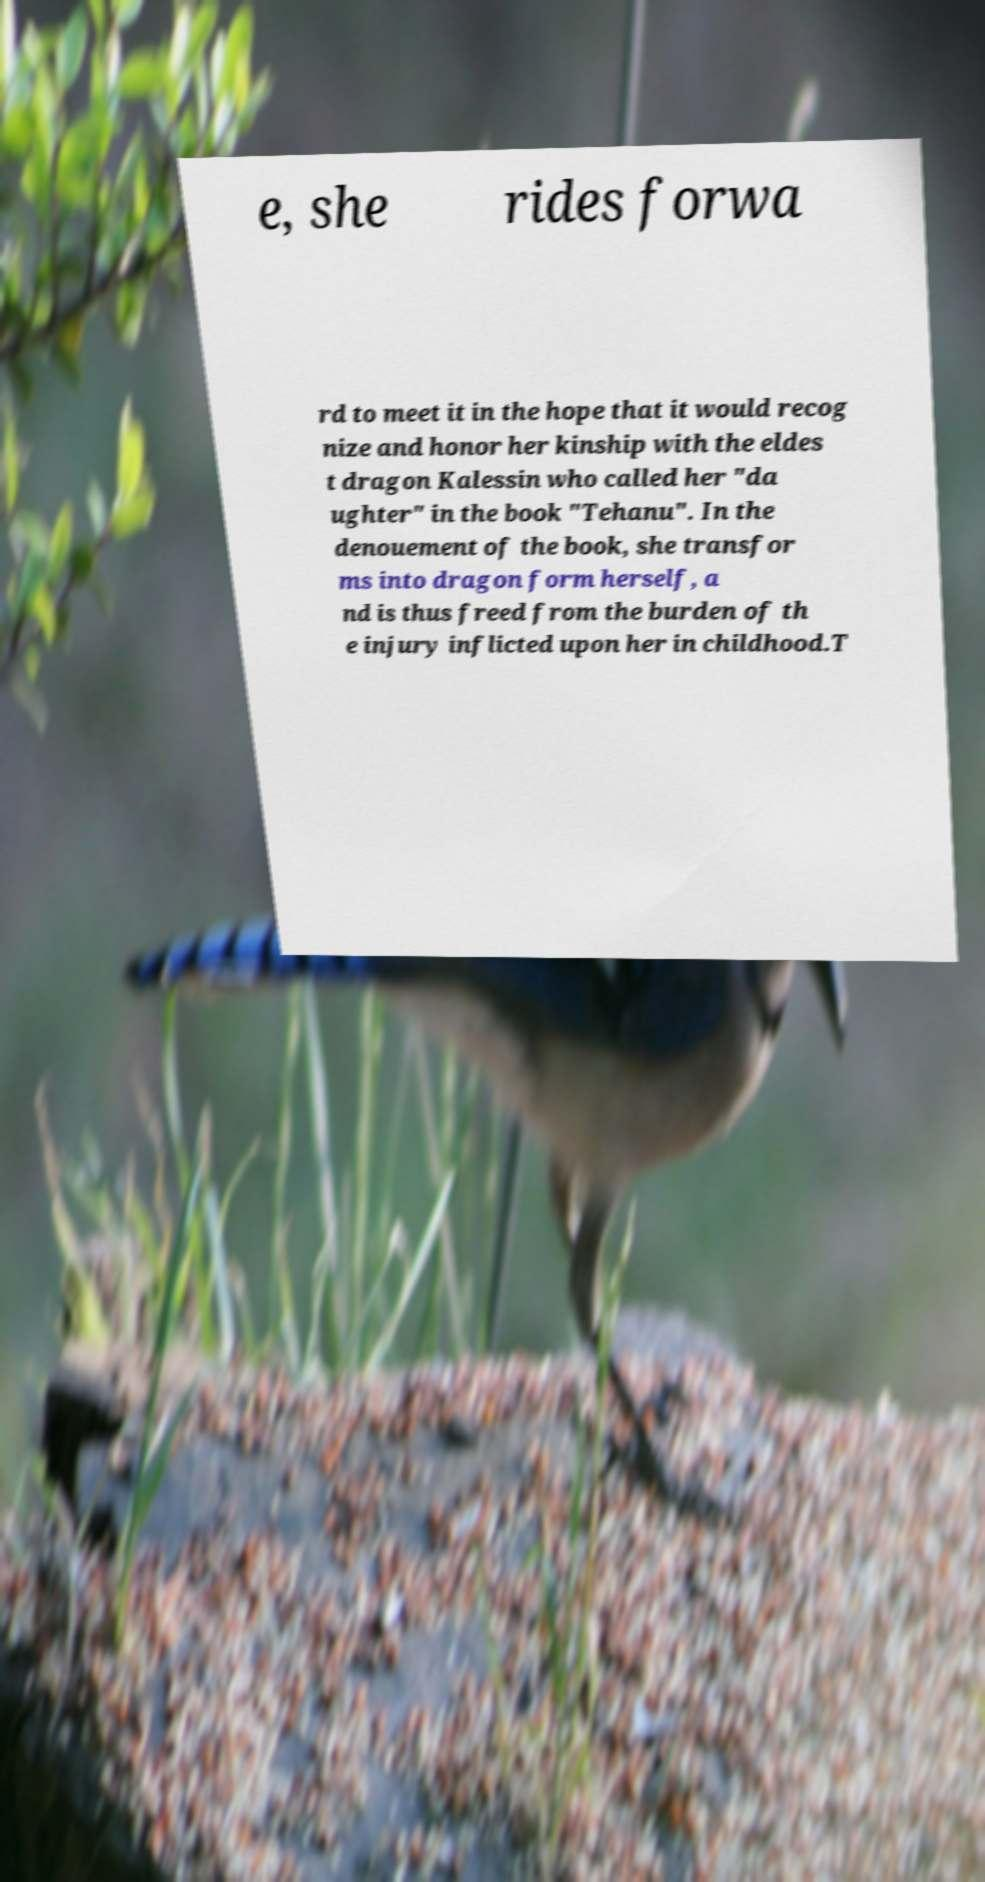I need the written content from this picture converted into text. Can you do that? e, she rides forwa rd to meet it in the hope that it would recog nize and honor her kinship with the eldes t dragon Kalessin who called her "da ughter" in the book "Tehanu". In the denouement of the book, she transfor ms into dragon form herself, a nd is thus freed from the burden of th e injury inflicted upon her in childhood.T 